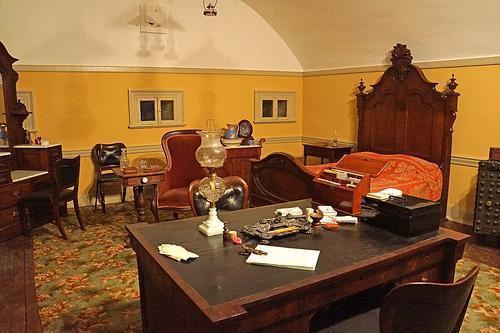How many beds are in the room?
Give a very brief answer. 1. 